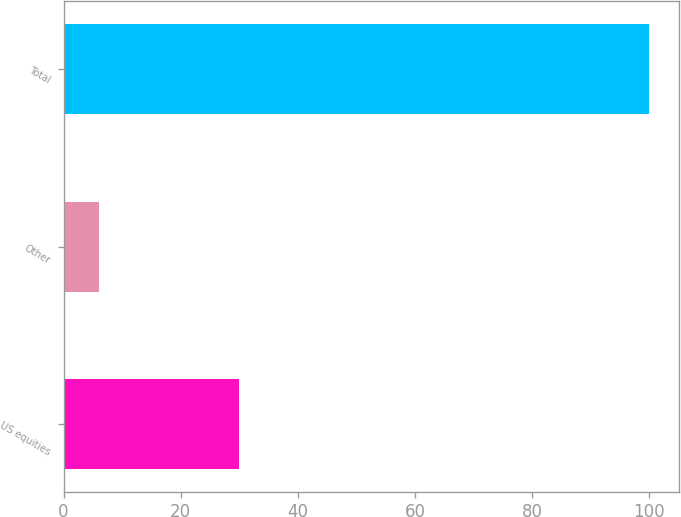Convert chart to OTSL. <chart><loc_0><loc_0><loc_500><loc_500><bar_chart><fcel>US equities<fcel>Other<fcel>Total<nl><fcel>30<fcel>6<fcel>100<nl></chart> 